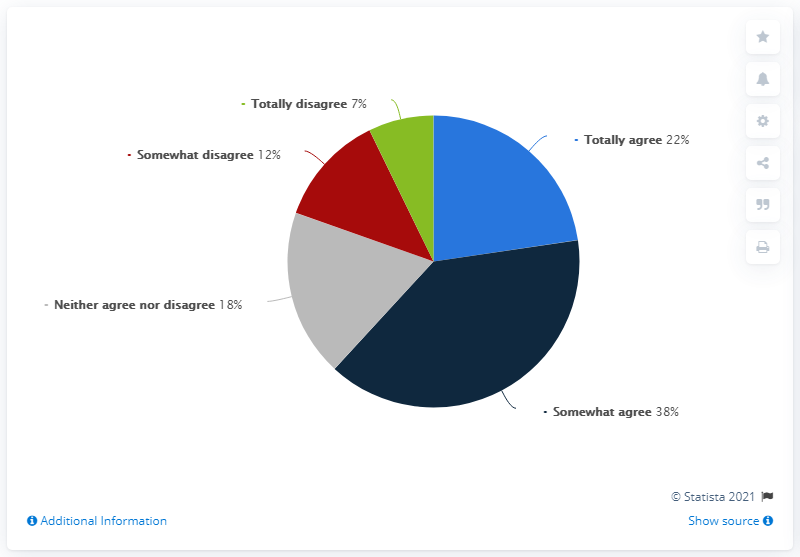Draw attention to some important aspects in this diagram. The average of "totally agree" and "somewhat agree" is 60. 